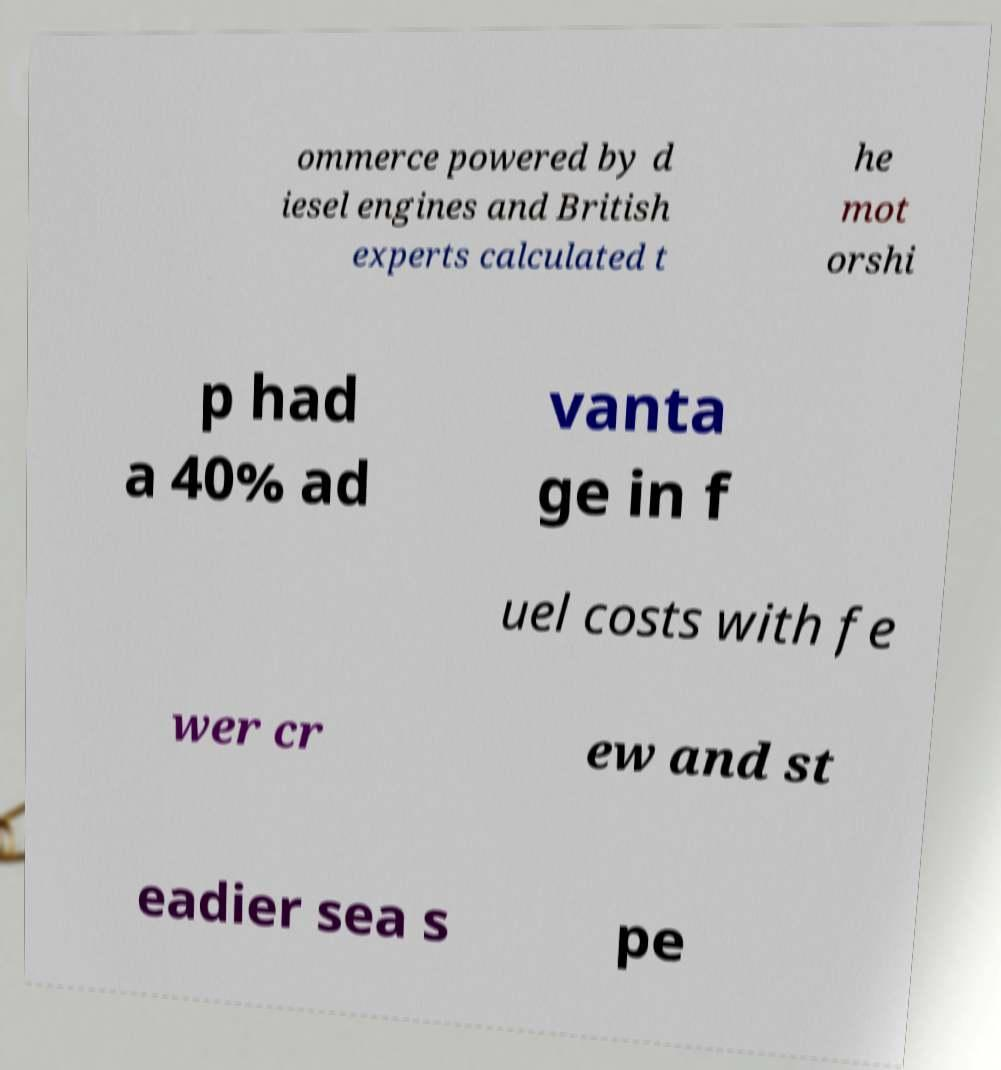Could you assist in decoding the text presented in this image and type it out clearly? ommerce powered by d iesel engines and British experts calculated t he mot orshi p had a 40% ad vanta ge in f uel costs with fe wer cr ew and st eadier sea s pe 